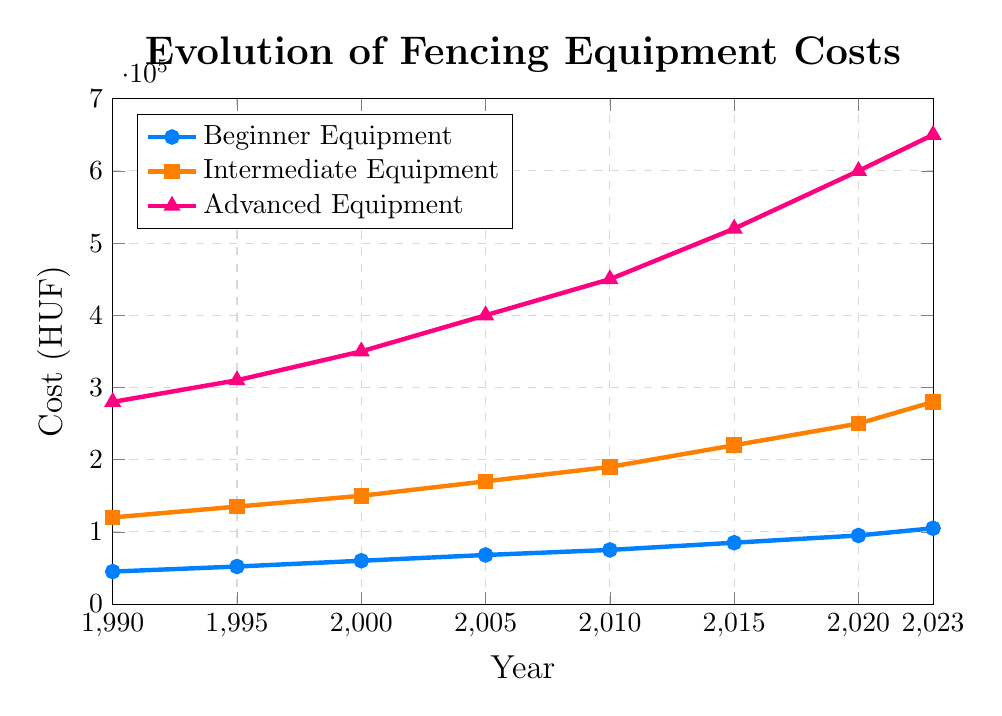Which category shows the most expensive equipment in 2023? The chart shows three categories: Beginner, Intermediate, and Advanced. By observing the visual height or Y-axis values in 2023, it’s clear that the Advanced Equipment is the highest cost.
Answer: Advanced Equipment How much did Beginner Equipment cost in 2000? Look at the line corresponding to Beginner Equipment and find the point in the year 2000. The Y-axis value at this point gives the cost.
Answer: 60,000 HUF By how much did the cost of Intermediate Equipment increase from 1990 to 2023? Find the Y-axis values of Intermediate Equipment for 1990 (120,000 HUF) and 2023 (280,000 HUF). Subtract the 1990 value from the 2023 value to get the increase.
Answer: 160,000 HUF Which category had the highest rate of price increase between 2010 and 2020? Calculate the price increase for each category by subtracting the 2010 value from the 2020 value. Compare the differences:
Beginner: 95,000 - 75,000 = 20,000
Intermediate: 250,000 - 190,000 = 60,000
Advanced: 600,000 - 450,000 = 150,000.
Advanced Equipment had the highest increase.
Answer: Advanced Equipment What is the average cost of Advanced Equipment from 1990 to 2023? Add the costs of Advanced Equipment for all years and divide by the number of years: 
(280,000 + 310,000 + 350,000 + 400,000 + 450,000 + 520,000 + 600,000 + 650,000) / 8.
Answer: 445,000 HUF In which year did Intermediate Equipment first exceed 200,000 HUF? Follow the Intermediate Equipment line and check each year's data point until the value surpasses 200,000 HUF. In 2015, the cost is 220,000 HUF.
Answer: 2015 Comparing Beginner and Advanced Equipment costs, in which year was the difference the greatest? For each year, subtract Beginner Equipment cost from Advanced Equipment cost and compare the results:
1990: 280,000 - 45,000 = 235,000
1995: 310,000 - 52,000 = 258,000
2000: 350,000 - 60,000 = 290,000
2005: 400,000 - 68,000 = 332,000
2010: 450,000 - 75,000 = 375,000
2015: 520,000 - 85,000 = 435,000
2020: 600,000 - 95,000 = 505,000
2023: 650,000 - 105,000 = 545,000.
The greatest difference is in 2023.
Answer: 2023 What is the cumulative cost of Beginner Equipment from 2000 to 2023? Add the costs of Beginner Equipment for each year from 2000 to 2023:
60,000 + 68,000 + 75,000 + 85,000 + 95,000 + 105,000.
Answer: 488,000 HUF 